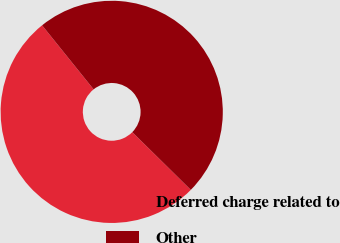Convert chart to OTSL. <chart><loc_0><loc_0><loc_500><loc_500><pie_chart><fcel>Deferred charge related to<fcel>Other<nl><fcel>51.83%<fcel>48.17%<nl></chart> 